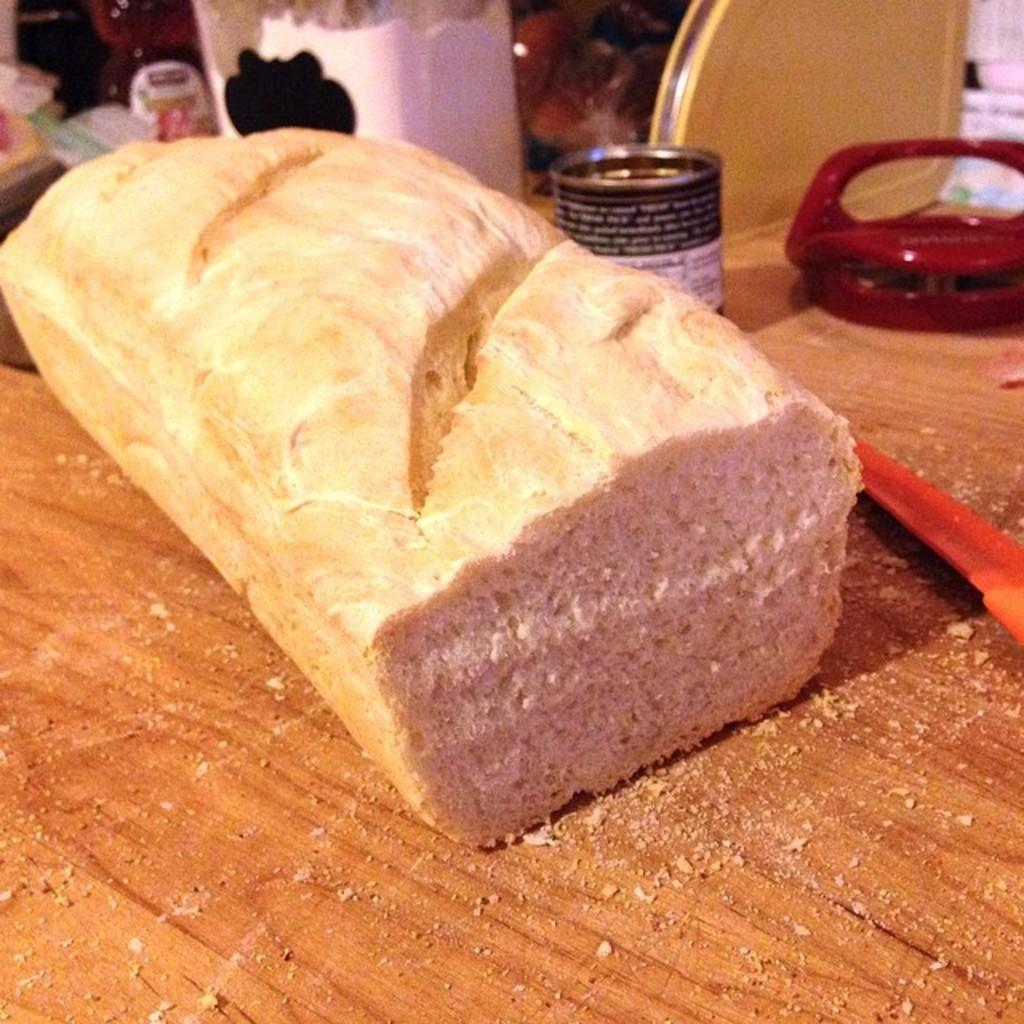What is placed on the table in the image? There is food placed on the table in the image. Can you describe any specific items on the table? There is a tin on the right side of the table. What else can be seen in the image besides the table and its contents? There are other things visible in the background of the image. What word is being spoken by the person walking at night in the image? There is no person walking at night in the image, and therefore no word being spoken. 